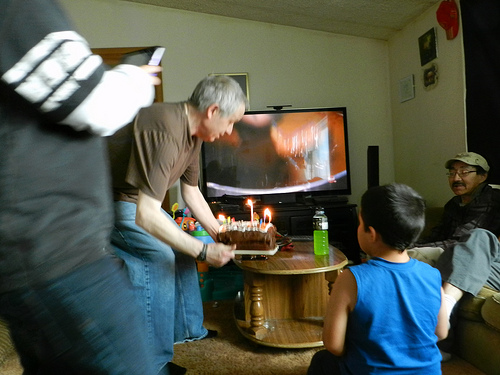How many people are wearing glasses in this image? In the image, there is only one person visibly wearing glasses. He appears seated to the right, engaging with the others in what seems to be a celebratory setting, possibly a birthday party. 